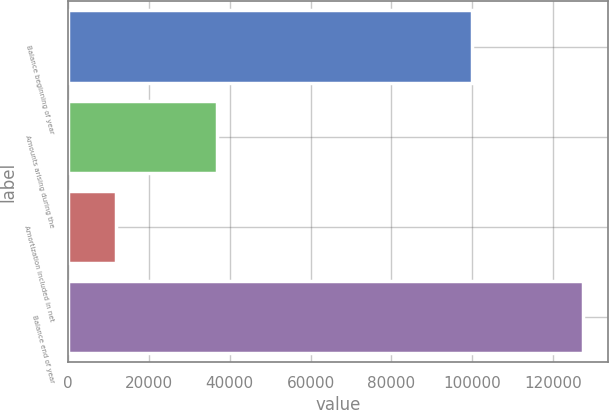<chart> <loc_0><loc_0><loc_500><loc_500><bar_chart><fcel>Balance beginning of year<fcel>Amounts arising during the<fcel>Amortization included in net<fcel>Balance end of year<nl><fcel>99813<fcel>36934<fcel>11858<fcel>127292<nl></chart> 